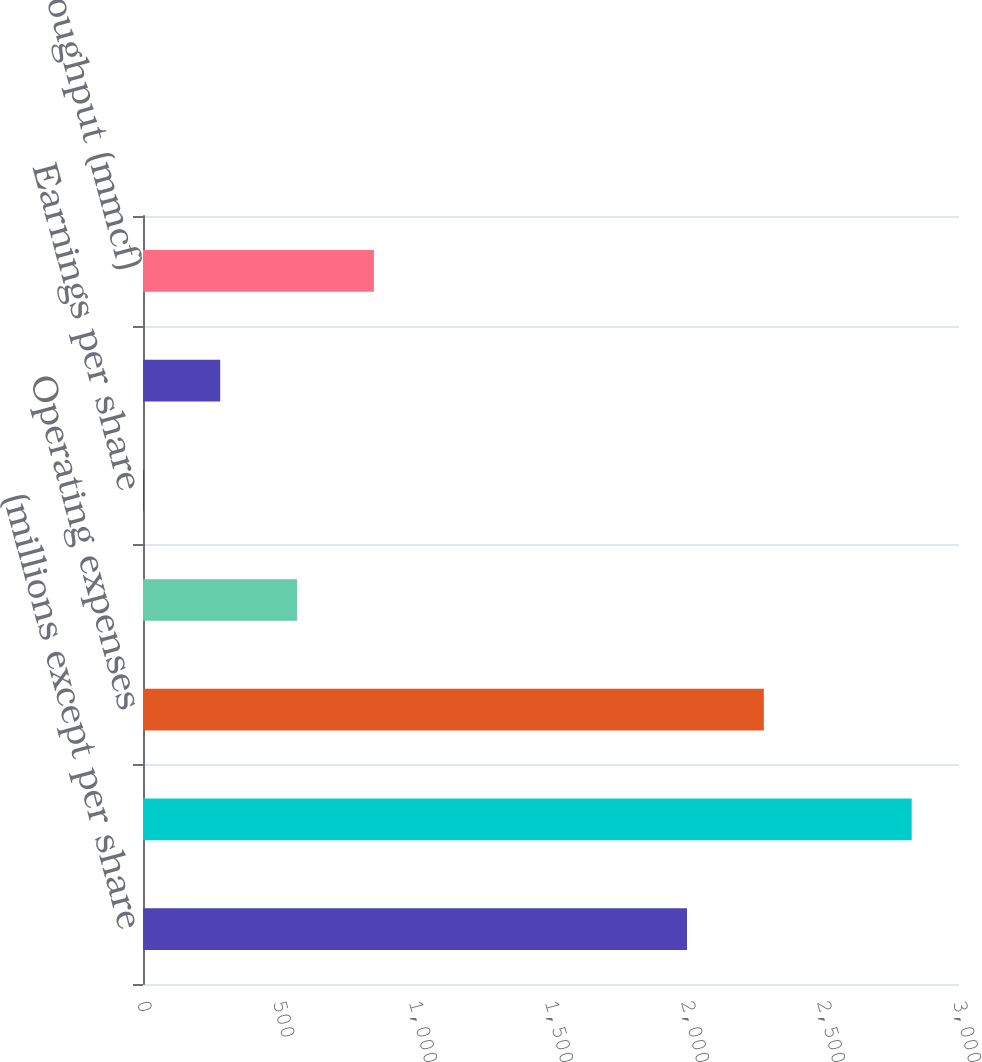<chart> <loc_0><loc_0><loc_500><loc_500><bar_chart><fcel>(millions except per share<fcel>Operating revenue<fcel>Operating expenses<fcel>Net income contribution<fcel>Earnings per share<fcel>Electricity delivered (million<fcel>Gas throughput (mmcf)<nl><fcel>2000<fcel>2826<fcel>2282.46<fcel>566.35<fcel>1.43<fcel>283.89<fcel>848.81<nl></chart> 